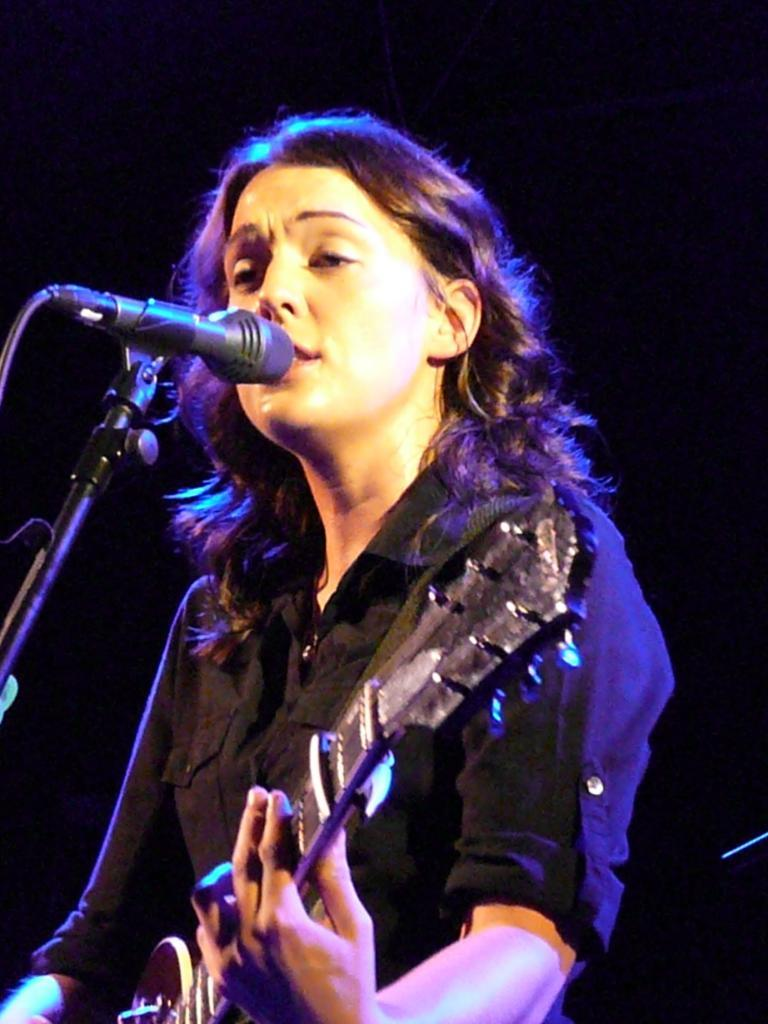Who is the main subject in the image? There is a woman in the image. What is the woman doing in the image? The woman is standing in the image. What object is the woman holding in her hand? The woman is holding a guitar in her hand. What is the purpose of the microphone and stand in front of the woman? The microphone and stand are likely used for amplifying the woman's voice while she plays the guitar. What type of wheel is visible in the image? There is no wheel present in the image. What health concerns might the woman have, based on the image? There is no information about the woman's health in the image, so it cannot be determined from the image alone. 